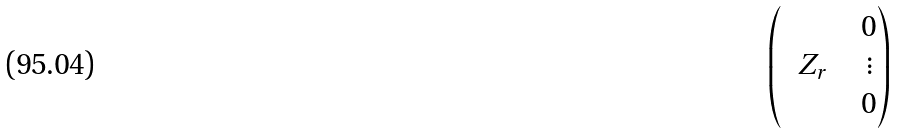<formula> <loc_0><loc_0><loc_500><loc_500>\begin{pmatrix} & & & 0 \\ & Z _ { r } & & \vdots \\ & & & 0 \end{pmatrix}</formula> 